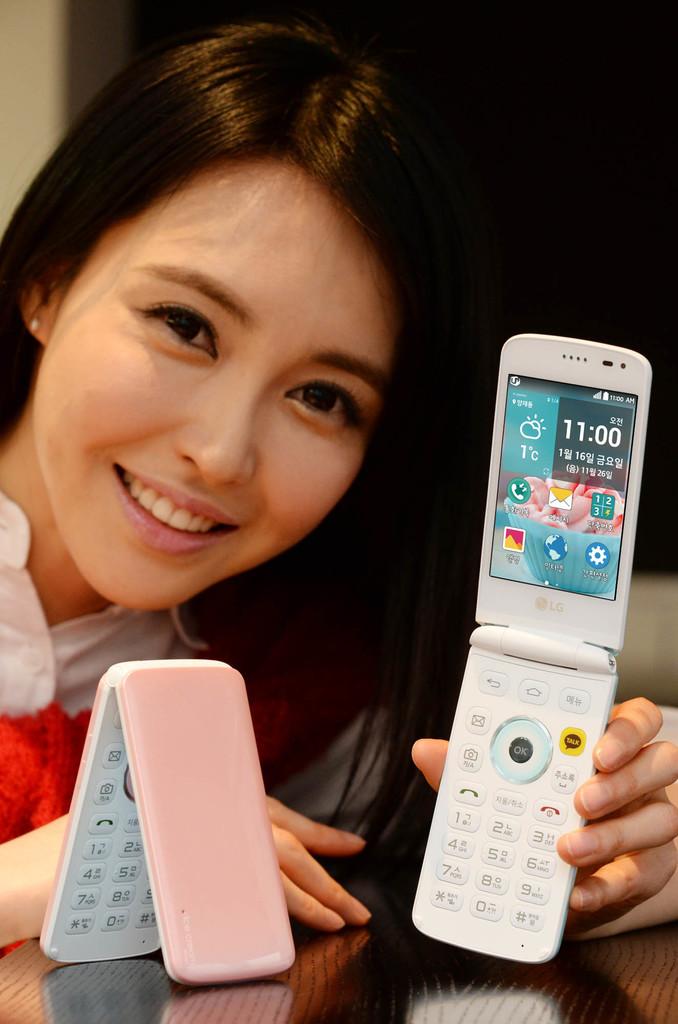What time is on the phone?
Provide a short and direct response. 11:00. What time is it on the phone?
Ensure brevity in your answer.  11:00. 